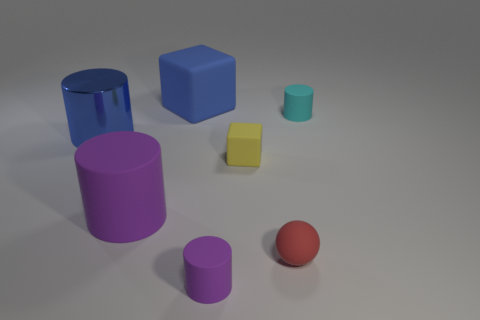Add 3 large blue shiny cylinders. How many objects exist? 10 Subtract all cubes. How many objects are left? 5 Subtract all tiny spheres. Subtract all big blue cylinders. How many objects are left? 5 Add 4 big blue cylinders. How many big blue cylinders are left? 5 Add 6 small objects. How many small objects exist? 10 Subtract 0 yellow spheres. How many objects are left? 7 